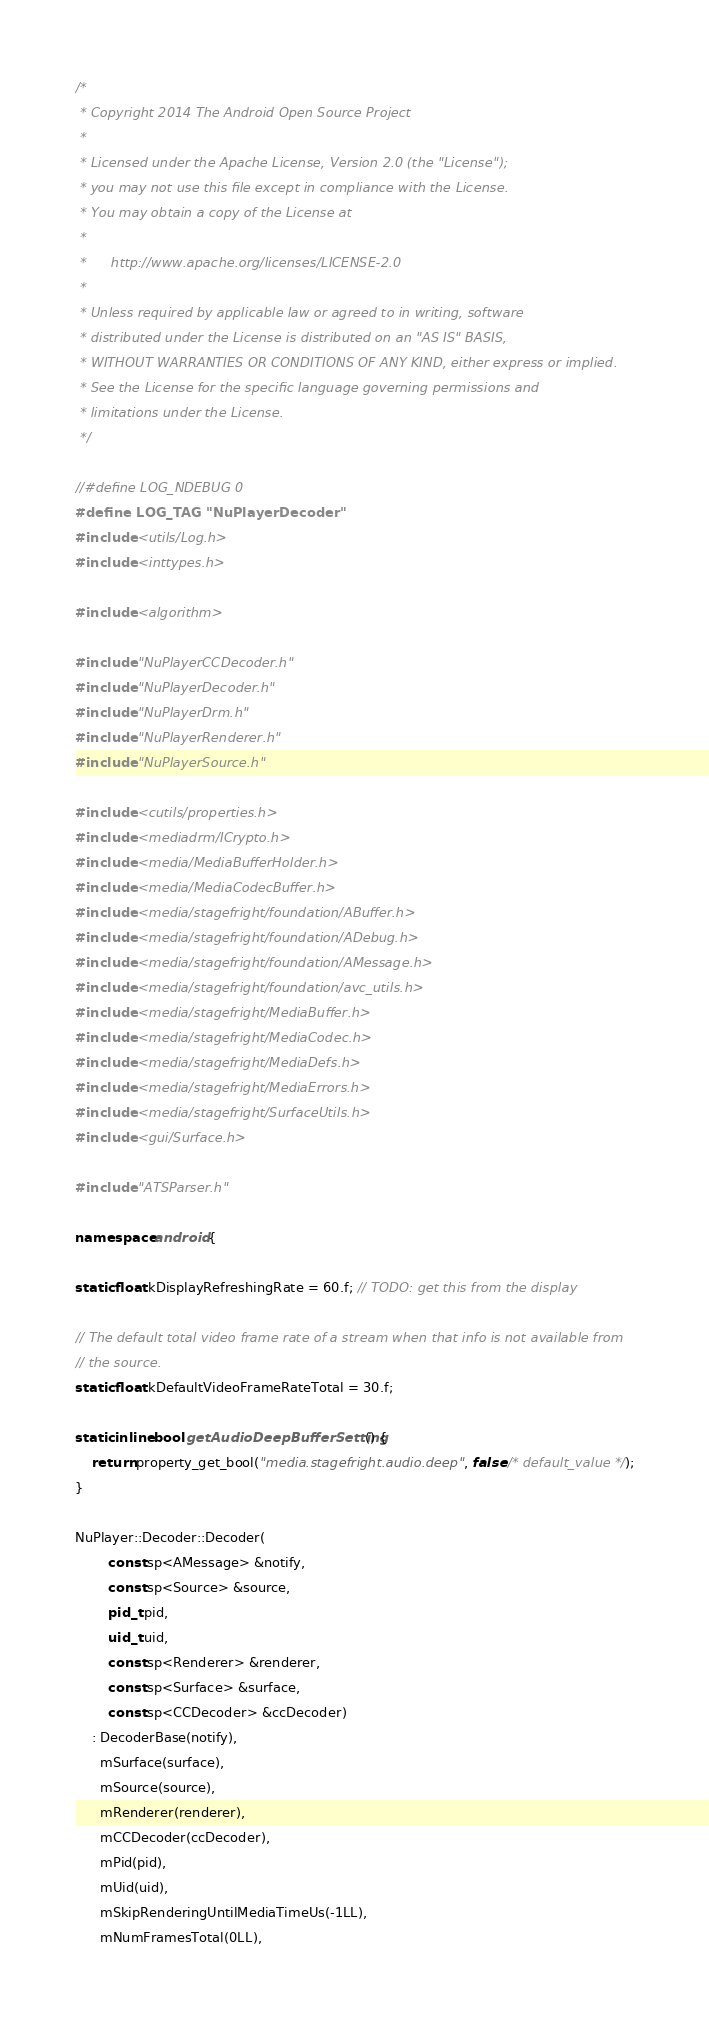<code> <loc_0><loc_0><loc_500><loc_500><_C++_>/*
 * Copyright 2014 The Android Open Source Project
 *
 * Licensed under the Apache License, Version 2.0 (the "License");
 * you may not use this file except in compliance with the License.
 * You may obtain a copy of the License at
 *
 *      http://www.apache.org/licenses/LICENSE-2.0
 *
 * Unless required by applicable law or agreed to in writing, software
 * distributed under the License is distributed on an "AS IS" BASIS,
 * WITHOUT WARRANTIES OR CONDITIONS OF ANY KIND, either express or implied.
 * See the License for the specific language governing permissions and
 * limitations under the License.
 */

//#define LOG_NDEBUG 0
#define LOG_TAG "NuPlayerDecoder"
#include <utils/Log.h>
#include <inttypes.h>

#include <algorithm>

#include "NuPlayerCCDecoder.h"
#include "NuPlayerDecoder.h"
#include "NuPlayerDrm.h"
#include "NuPlayerRenderer.h"
#include "NuPlayerSource.h"

#include <cutils/properties.h>
#include <mediadrm/ICrypto.h>
#include <media/MediaBufferHolder.h>
#include <media/MediaCodecBuffer.h>
#include <media/stagefright/foundation/ABuffer.h>
#include <media/stagefright/foundation/ADebug.h>
#include <media/stagefright/foundation/AMessage.h>
#include <media/stagefright/foundation/avc_utils.h>
#include <media/stagefright/MediaBuffer.h>
#include <media/stagefright/MediaCodec.h>
#include <media/stagefright/MediaDefs.h>
#include <media/stagefright/MediaErrors.h>
#include <media/stagefright/SurfaceUtils.h>
#include <gui/Surface.h>

#include "ATSParser.h"

namespace android {

static float kDisplayRefreshingRate = 60.f; // TODO: get this from the display

// The default total video frame rate of a stream when that info is not available from
// the source.
static float kDefaultVideoFrameRateTotal = 30.f;

static inline bool getAudioDeepBufferSetting() {
    return property_get_bool("media.stagefright.audio.deep", false /* default_value */);
}

NuPlayer::Decoder::Decoder(
        const sp<AMessage> &notify,
        const sp<Source> &source,
        pid_t pid,
        uid_t uid,
        const sp<Renderer> &renderer,
        const sp<Surface> &surface,
        const sp<CCDecoder> &ccDecoder)
    : DecoderBase(notify),
      mSurface(surface),
      mSource(source),
      mRenderer(renderer),
      mCCDecoder(ccDecoder),
      mPid(pid),
      mUid(uid),
      mSkipRenderingUntilMediaTimeUs(-1LL),
      mNumFramesTotal(0LL),</code> 